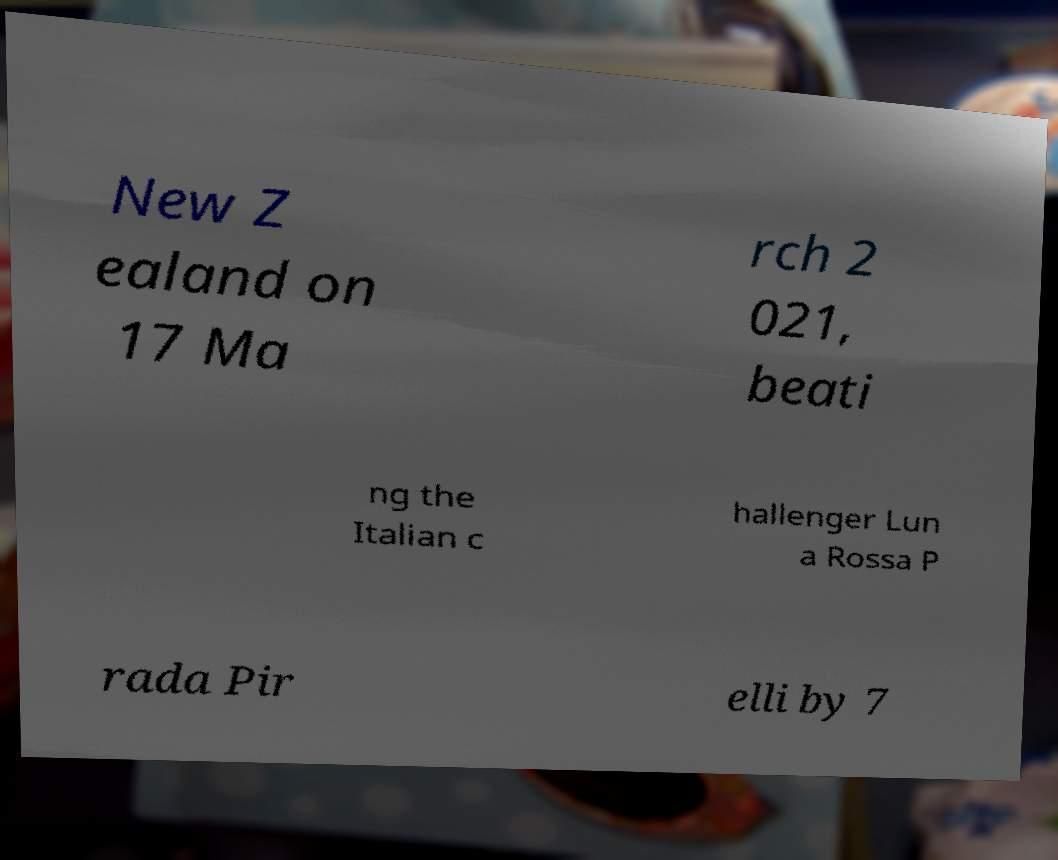Can you accurately transcribe the text from the provided image for me? New Z ealand on 17 Ma rch 2 021, beati ng the Italian c hallenger Lun a Rossa P rada Pir elli by 7 